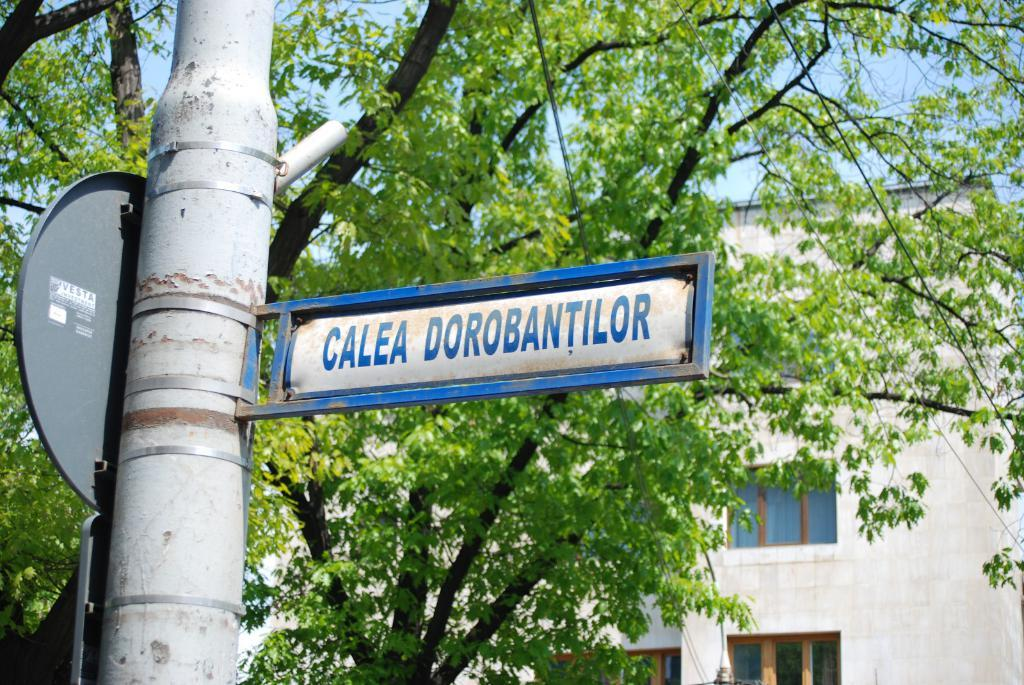<image>
Relay a brief, clear account of the picture shown. Calea Dorobantilor road sign on a silver pole. 